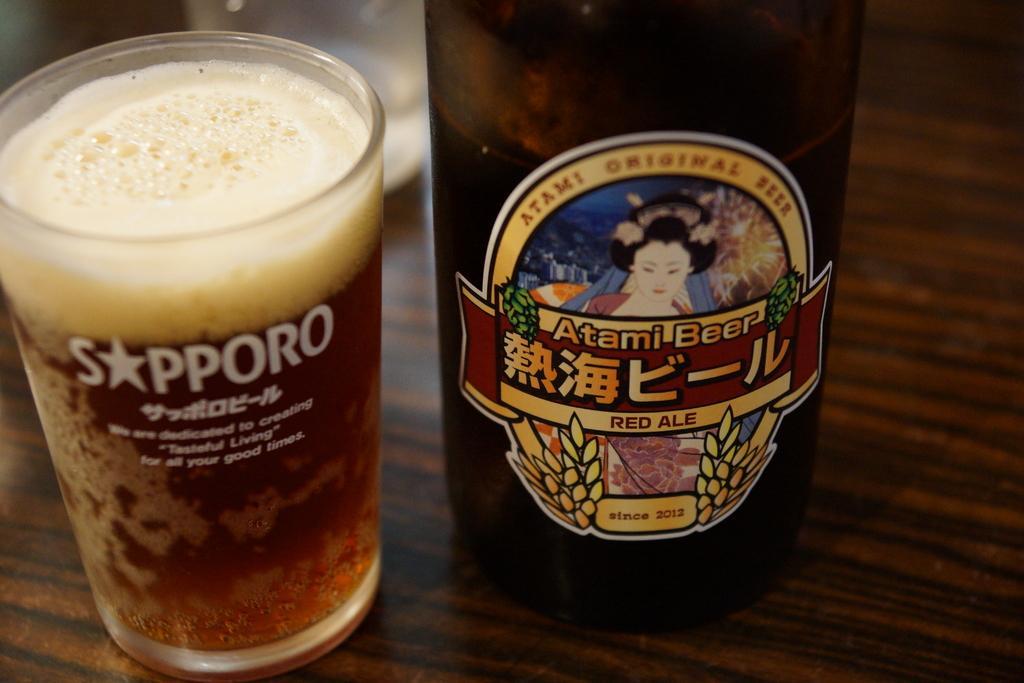Describe this image in one or two sentences. We can see glass with drink,bottle and we can see sticker on this bottle. 